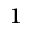Convert formula to latex. <formula><loc_0><loc_0><loc_500><loc_500>^ { 1 }</formula> 